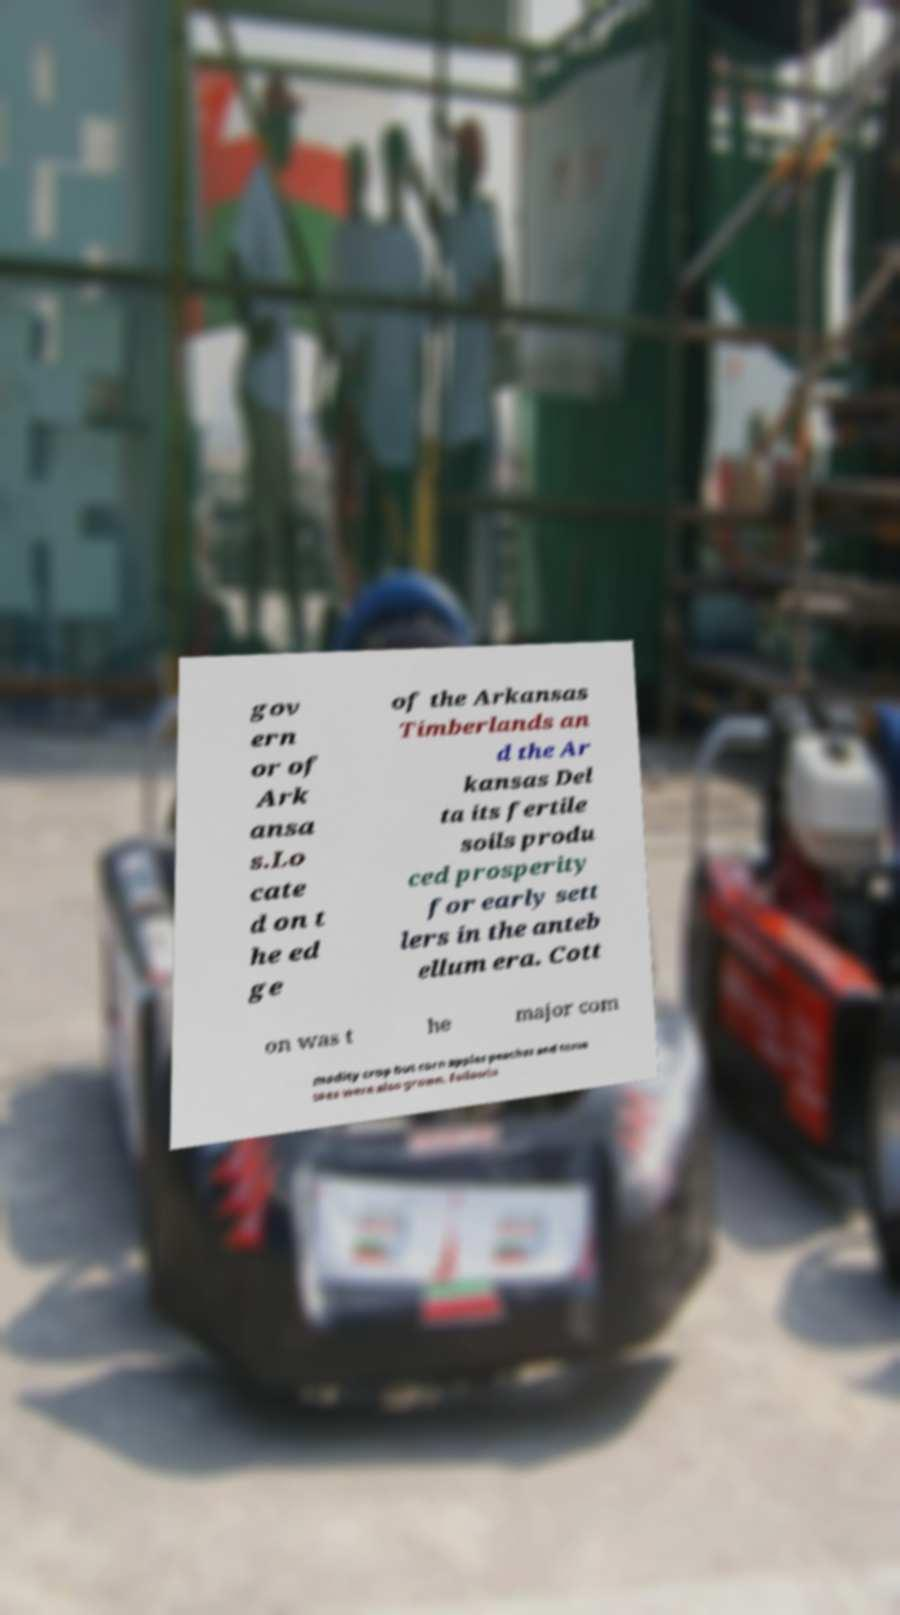For documentation purposes, I need the text within this image transcribed. Could you provide that? gov ern or of Ark ansa s.Lo cate d on t he ed ge of the Arkansas Timberlands an d the Ar kansas Del ta its fertile soils produ ced prosperity for early sett lers in the anteb ellum era. Cott on was t he major com modity crop but corn apples peaches and toma toes were also grown. Followin 